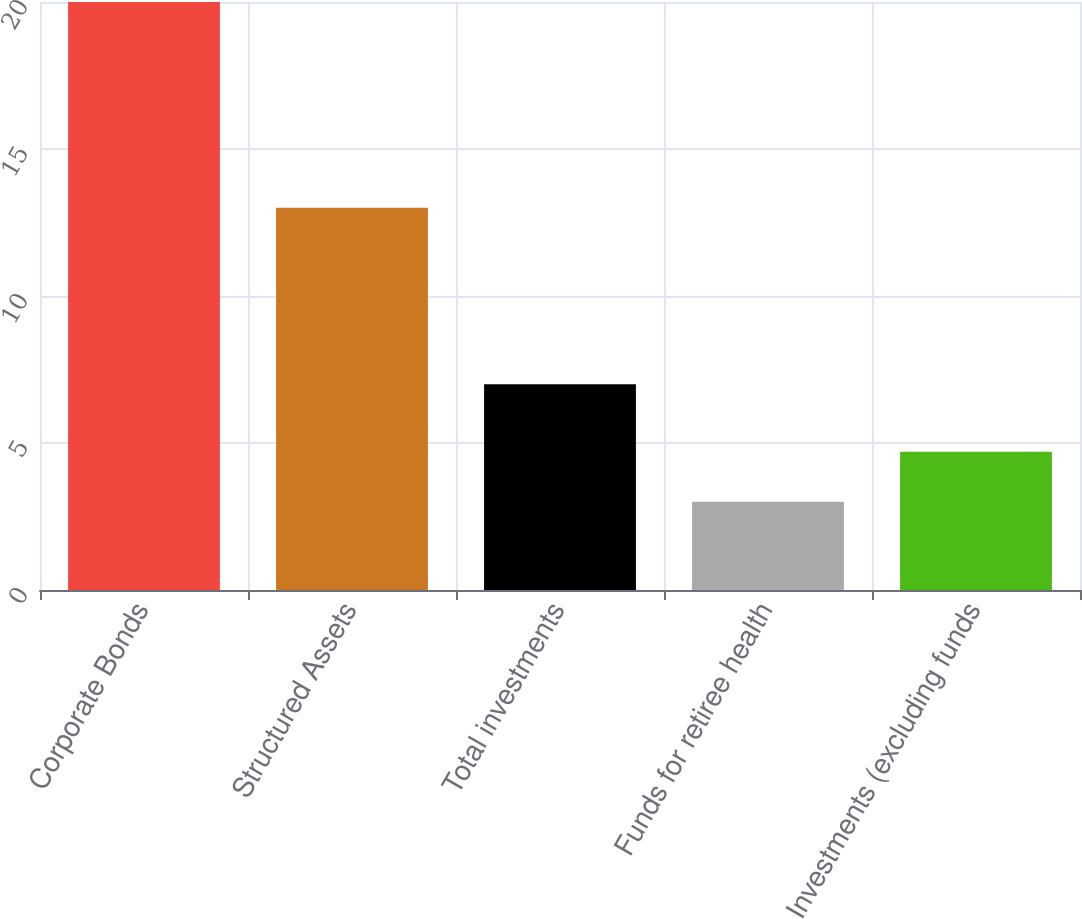Convert chart to OTSL. <chart><loc_0><loc_0><loc_500><loc_500><bar_chart><fcel>Corporate Bonds<fcel>Structured Assets<fcel>Total investments<fcel>Funds for retiree health<fcel>Investments (excluding funds<nl><fcel>20<fcel>13<fcel>7<fcel>3<fcel>4.7<nl></chart> 